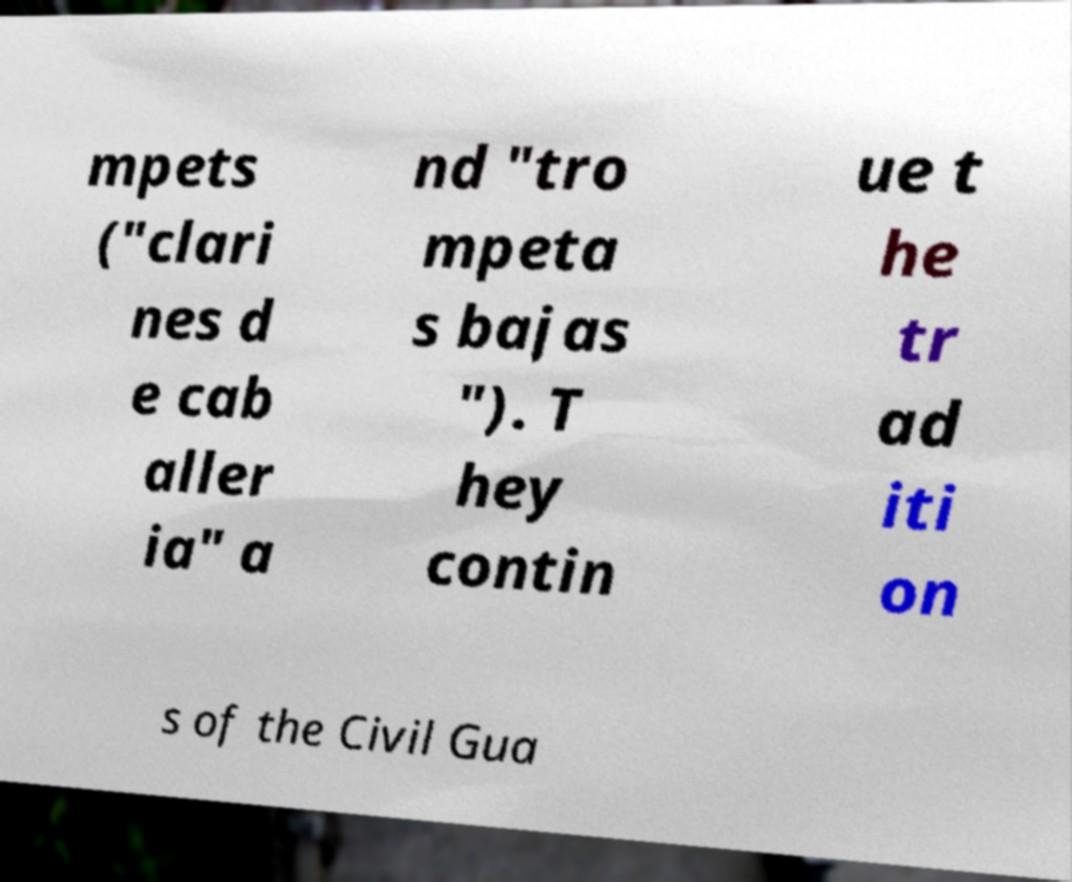Can you accurately transcribe the text from the provided image for me? mpets ("clari nes d e cab aller ia" a nd "tro mpeta s bajas "). T hey contin ue t he tr ad iti on s of the Civil Gua 